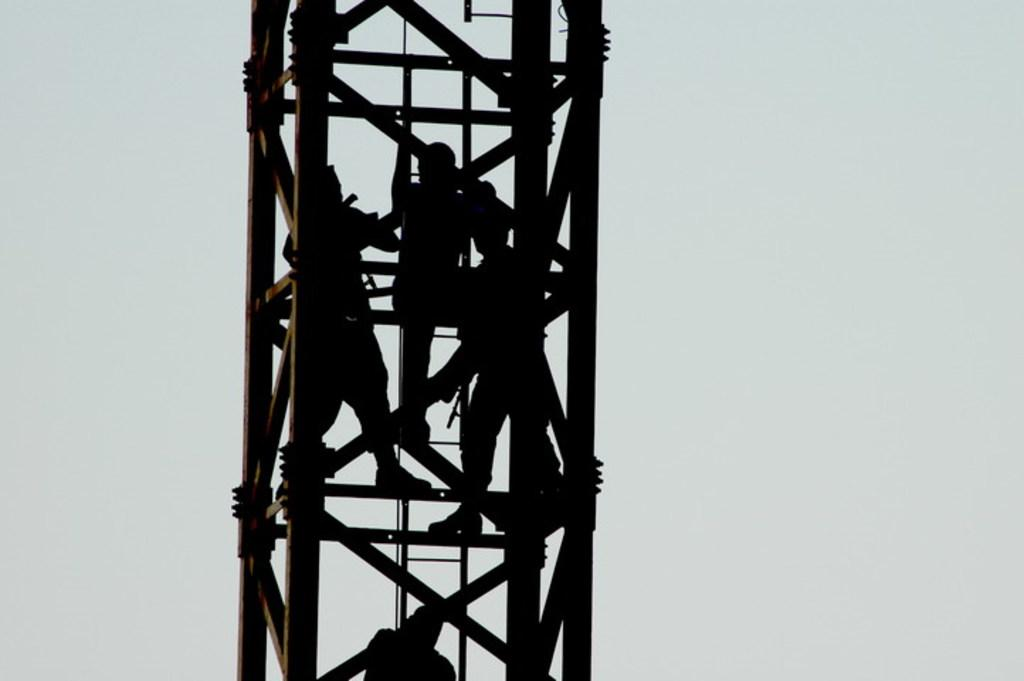How many people are in the image? The number of people in the image cannot be determined from the provided facts. What are the people in the image doing? The people in the image are climbing a tower. What type of root can be seen growing on the side of the tower in the image? There is no root visible on the side of the tower in the image. 